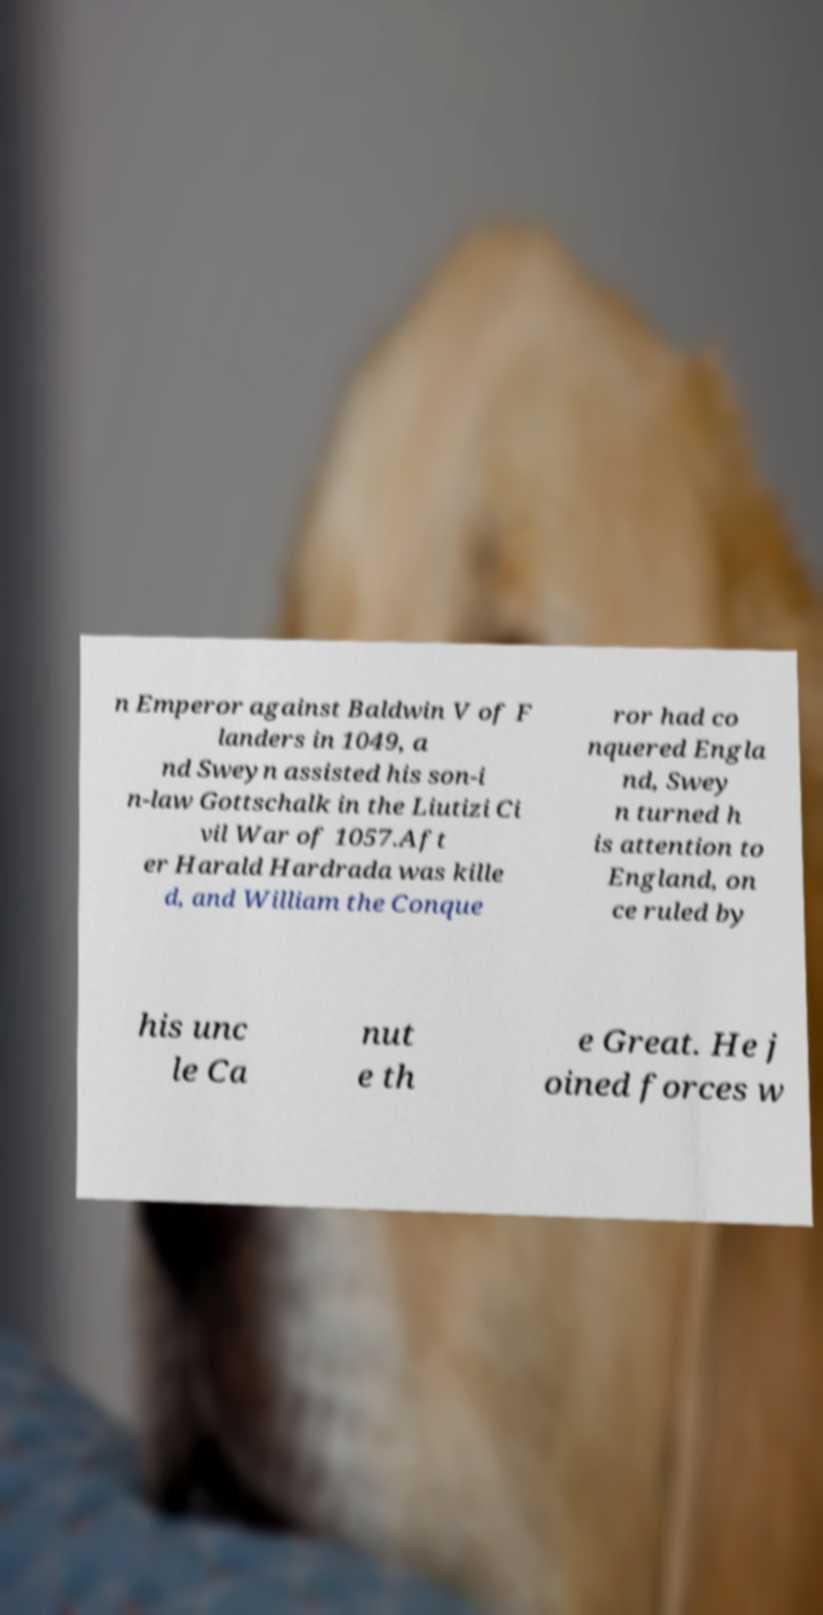Can you accurately transcribe the text from the provided image for me? n Emperor against Baldwin V of F landers in 1049, a nd Sweyn assisted his son-i n-law Gottschalk in the Liutizi Ci vil War of 1057.Aft er Harald Hardrada was kille d, and William the Conque ror had co nquered Engla nd, Swey n turned h is attention to England, on ce ruled by his unc le Ca nut e th e Great. He j oined forces w 